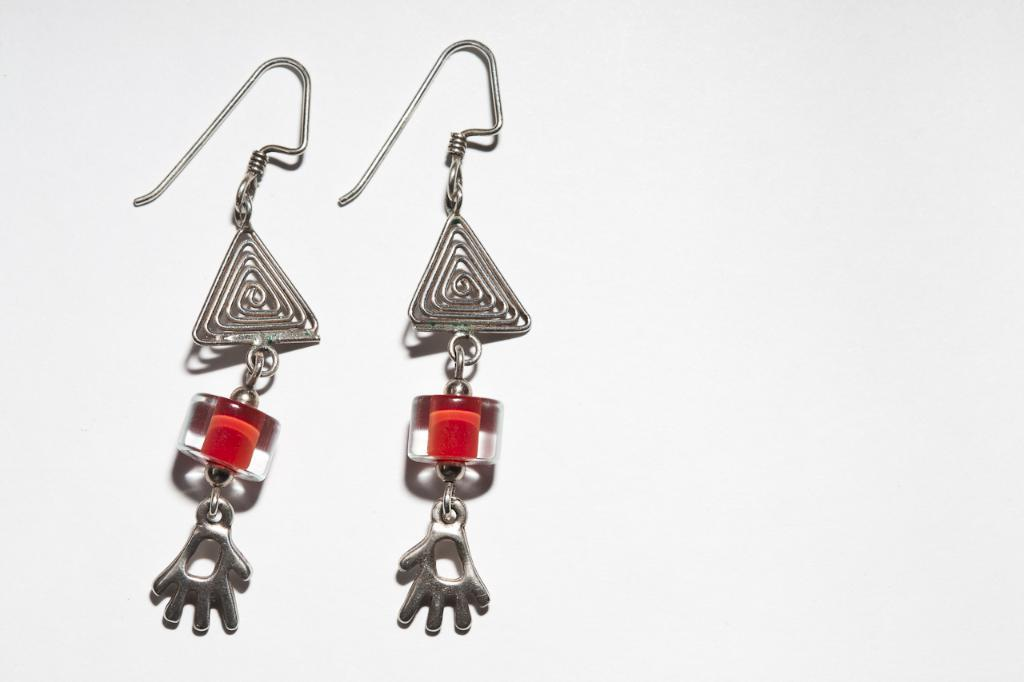What type of jewelry is present in the image? There are two earrings in the image. What is the color of the earrings? The earrings are silver in color. What other objects in the image have a red color? There are red-colored objects in the image. What is the color of the background in the image? The background of the image is white. How many feet are visible in the image? There are no feet visible in the image. What type of beam is supporting the structure in the image? There is no structure or beam present in the image. 